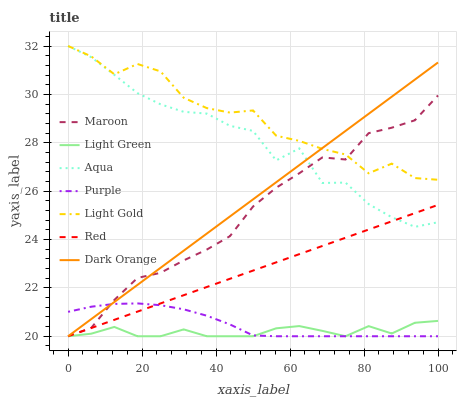Does Light Green have the minimum area under the curve?
Answer yes or no. Yes. Does Purple have the minimum area under the curve?
Answer yes or no. No. Does Purple have the maximum area under the curve?
Answer yes or no. No. Is Purple the smoothest?
Answer yes or no. No. Is Purple the roughest?
Answer yes or no. No. Does Aqua have the lowest value?
Answer yes or no. No. Does Purple have the highest value?
Answer yes or no. No. Is Light Green less than Light Gold?
Answer yes or no. Yes. Is Light Gold greater than Light Green?
Answer yes or no. Yes. Does Light Green intersect Light Gold?
Answer yes or no. No. 